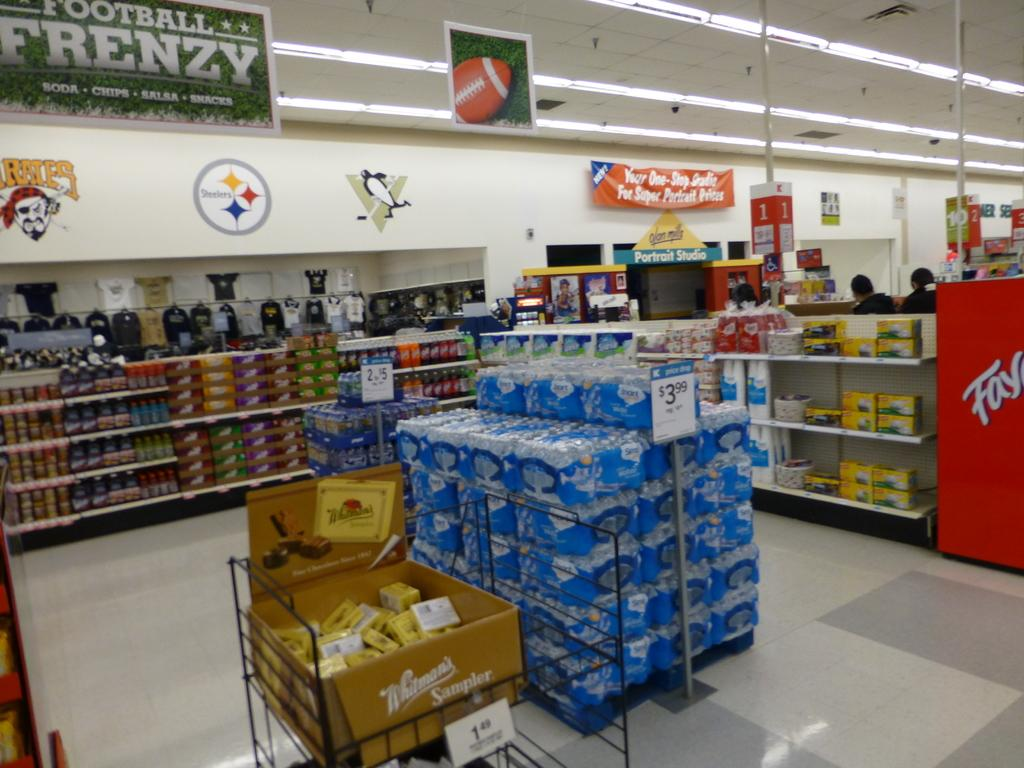<image>
Render a clear and concise summary of the photo. Several box's of Whitmans Sampler candy sit in a display box 